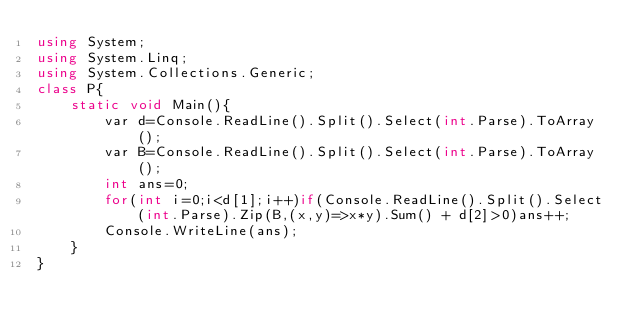Convert code to text. <code><loc_0><loc_0><loc_500><loc_500><_C#_>using System;
using System.Linq;
using System.Collections.Generic;
class P{
    static void Main(){
        var d=Console.ReadLine().Split().Select(int.Parse).ToArray();
        var B=Console.ReadLine().Split().Select(int.Parse).ToArray();
        int ans=0;
        for(int i=0;i<d[1];i++)if(Console.ReadLine().Split().Select(int.Parse).Zip(B,(x,y)=>x*y).Sum() + d[2]>0)ans++;
        Console.WriteLine(ans);
    }
}</code> 